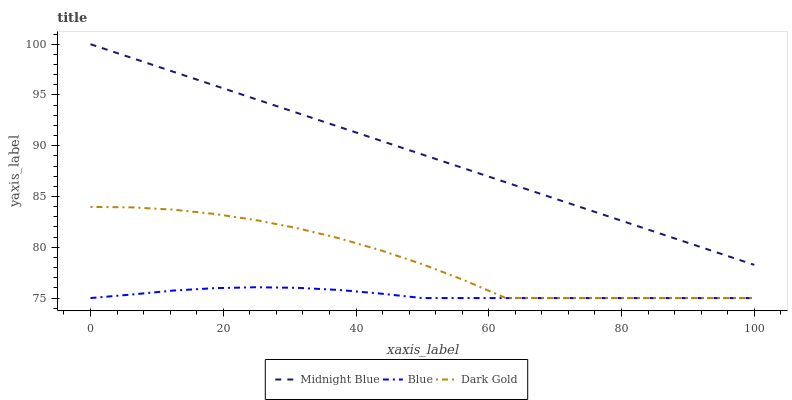Does Blue have the minimum area under the curve?
Answer yes or no. Yes. Does Midnight Blue have the maximum area under the curve?
Answer yes or no. Yes. Does Dark Gold have the minimum area under the curve?
Answer yes or no. No. Does Dark Gold have the maximum area under the curve?
Answer yes or no. No. Is Midnight Blue the smoothest?
Answer yes or no. Yes. Is Dark Gold the roughest?
Answer yes or no. Yes. Is Dark Gold the smoothest?
Answer yes or no. No. Is Midnight Blue the roughest?
Answer yes or no. No. Does Midnight Blue have the lowest value?
Answer yes or no. No. Does Dark Gold have the highest value?
Answer yes or no. No. Is Blue less than Midnight Blue?
Answer yes or no. Yes. Is Midnight Blue greater than Blue?
Answer yes or no. Yes. Does Blue intersect Midnight Blue?
Answer yes or no. No. 